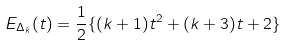<formula> <loc_0><loc_0><loc_500><loc_500>E _ { \Delta _ { k } } ( t ) = \frac { 1 } { 2 } \{ ( k + 1 ) t ^ { 2 } + ( k + 3 ) t + 2 \}</formula> 